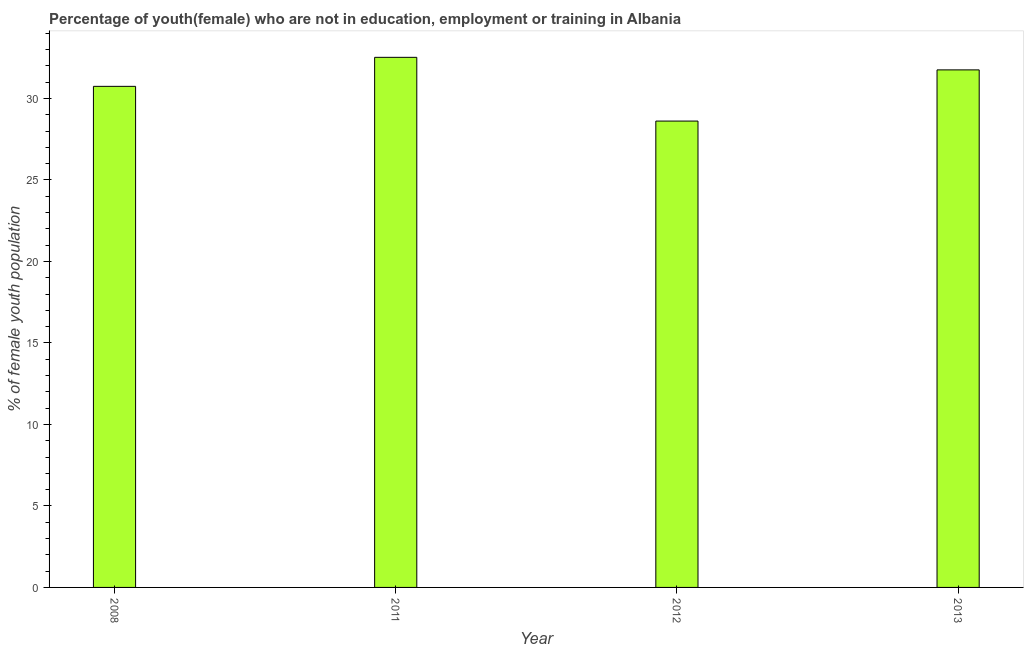Does the graph contain grids?
Keep it short and to the point. No. What is the title of the graph?
Ensure brevity in your answer.  Percentage of youth(female) who are not in education, employment or training in Albania. What is the label or title of the Y-axis?
Ensure brevity in your answer.  % of female youth population. What is the unemployed female youth population in 2011?
Ensure brevity in your answer.  32.52. Across all years, what is the maximum unemployed female youth population?
Provide a succinct answer. 32.52. Across all years, what is the minimum unemployed female youth population?
Your response must be concise. 28.61. In which year was the unemployed female youth population maximum?
Your answer should be very brief. 2011. What is the sum of the unemployed female youth population?
Provide a succinct answer. 123.62. What is the difference between the unemployed female youth population in 2008 and 2012?
Offer a very short reply. 2.13. What is the average unemployed female youth population per year?
Keep it short and to the point. 30.91. What is the median unemployed female youth population?
Ensure brevity in your answer.  31.24. Do a majority of the years between 2008 and 2011 (inclusive) have unemployed female youth population greater than 2 %?
Ensure brevity in your answer.  Yes. What is the ratio of the unemployed female youth population in 2011 to that in 2012?
Your response must be concise. 1.14. Is the difference between the unemployed female youth population in 2008 and 2012 greater than the difference between any two years?
Give a very brief answer. No. What is the difference between the highest and the second highest unemployed female youth population?
Keep it short and to the point. 0.77. What is the difference between the highest and the lowest unemployed female youth population?
Keep it short and to the point. 3.91. In how many years, is the unemployed female youth population greater than the average unemployed female youth population taken over all years?
Provide a succinct answer. 2. How many years are there in the graph?
Your answer should be very brief. 4. What is the difference between two consecutive major ticks on the Y-axis?
Offer a very short reply. 5. What is the % of female youth population of 2008?
Give a very brief answer. 30.74. What is the % of female youth population of 2011?
Your response must be concise. 32.52. What is the % of female youth population of 2012?
Offer a very short reply. 28.61. What is the % of female youth population in 2013?
Your answer should be compact. 31.75. What is the difference between the % of female youth population in 2008 and 2011?
Your response must be concise. -1.78. What is the difference between the % of female youth population in 2008 and 2012?
Ensure brevity in your answer.  2.13. What is the difference between the % of female youth population in 2008 and 2013?
Give a very brief answer. -1.01. What is the difference between the % of female youth population in 2011 and 2012?
Your response must be concise. 3.91. What is the difference between the % of female youth population in 2011 and 2013?
Your answer should be very brief. 0.77. What is the difference between the % of female youth population in 2012 and 2013?
Offer a very short reply. -3.14. What is the ratio of the % of female youth population in 2008 to that in 2011?
Provide a succinct answer. 0.94. What is the ratio of the % of female youth population in 2008 to that in 2012?
Offer a very short reply. 1.07. What is the ratio of the % of female youth population in 2011 to that in 2012?
Provide a succinct answer. 1.14. What is the ratio of the % of female youth population in 2012 to that in 2013?
Ensure brevity in your answer.  0.9. 